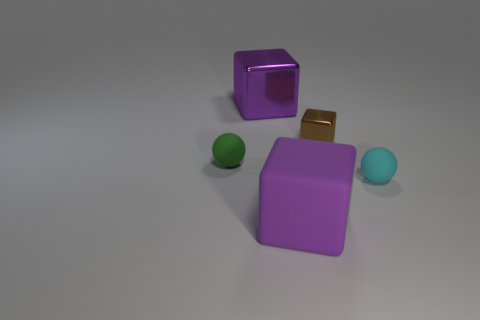Subtract all big cubes. How many cubes are left? 1 Subtract 2 cubes. How many cubes are left? 1 Add 2 large yellow shiny cylinders. How many objects exist? 7 Subtract all brown blocks. How many blocks are left? 2 Subtract all cubes. How many objects are left? 2 Subtract all blue cubes. How many cyan spheres are left? 1 Subtract all tiny yellow objects. Subtract all cyan spheres. How many objects are left? 4 Add 5 small objects. How many small objects are left? 8 Add 3 tiny cyan objects. How many tiny cyan objects exist? 4 Subtract 0 blue balls. How many objects are left? 5 